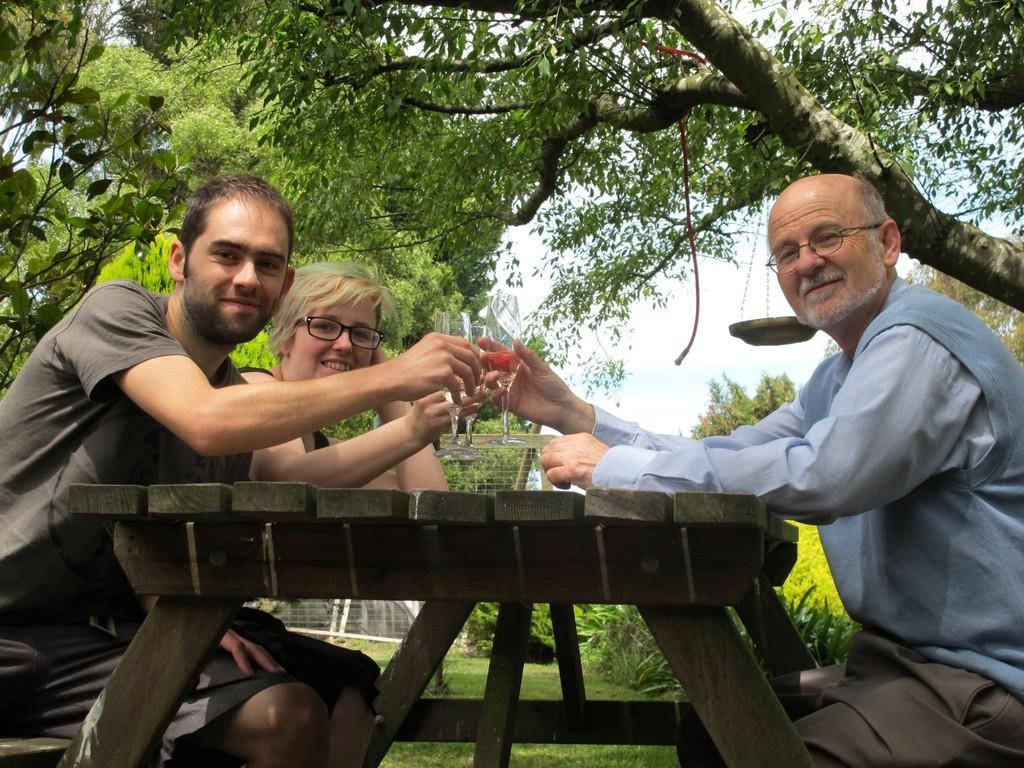In one or two sentences, can you explain what this image depicts? in this picture we can see a man is sitting on a chair and smiling and holding a glass in her hand, and in front there is the table ,and to opposite him a person is sitting, and to beside him a woman is sitting and holding a wine glass in her hand, and at the top there are trees, and here is the sky. 